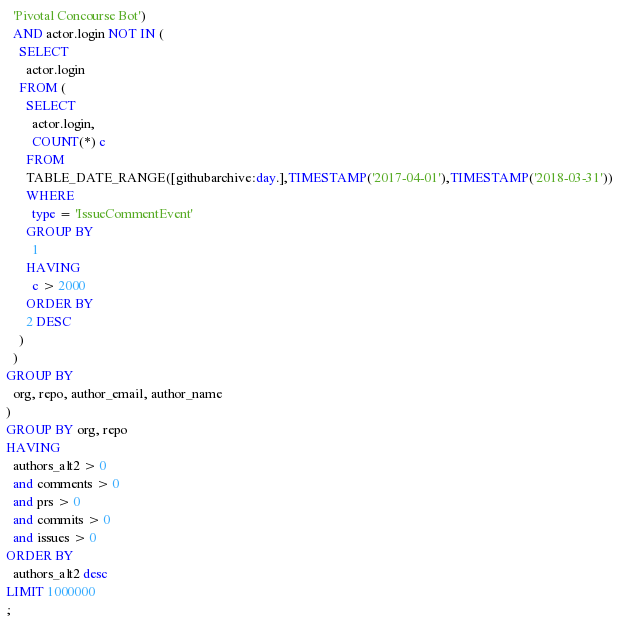Convert code to text. <code><loc_0><loc_0><loc_500><loc_500><_SQL_>  'Pivotal Concourse Bot')
  AND actor.login NOT IN (
    SELECT
      actor.login
    FROM (
      SELECT
        actor.login,
        COUNT(*) c
      FROM
      TABLE_DATE_RANGE([githubarchive:day.],TIMESTAMP('2017-04-01'),TIMESTAMP('2018-03-31'))
      WHERE
        type = 'IssueCommentEvent'
      GROUP BY
        1
      HAVING
        c > 2000
      ORDER BY
      2 DESC
    )
  )
GROUP BY
  org, repo, author_email, author_name
)
GROUP BY org, repo
HAVING
  authors_alt2 > 0
  and comments > 0
  and prs > 0
  and commits > 0
  and issues > 0
ORDER BY
  authors_alt2 desc
LIMIT 1000000
;

</code> 